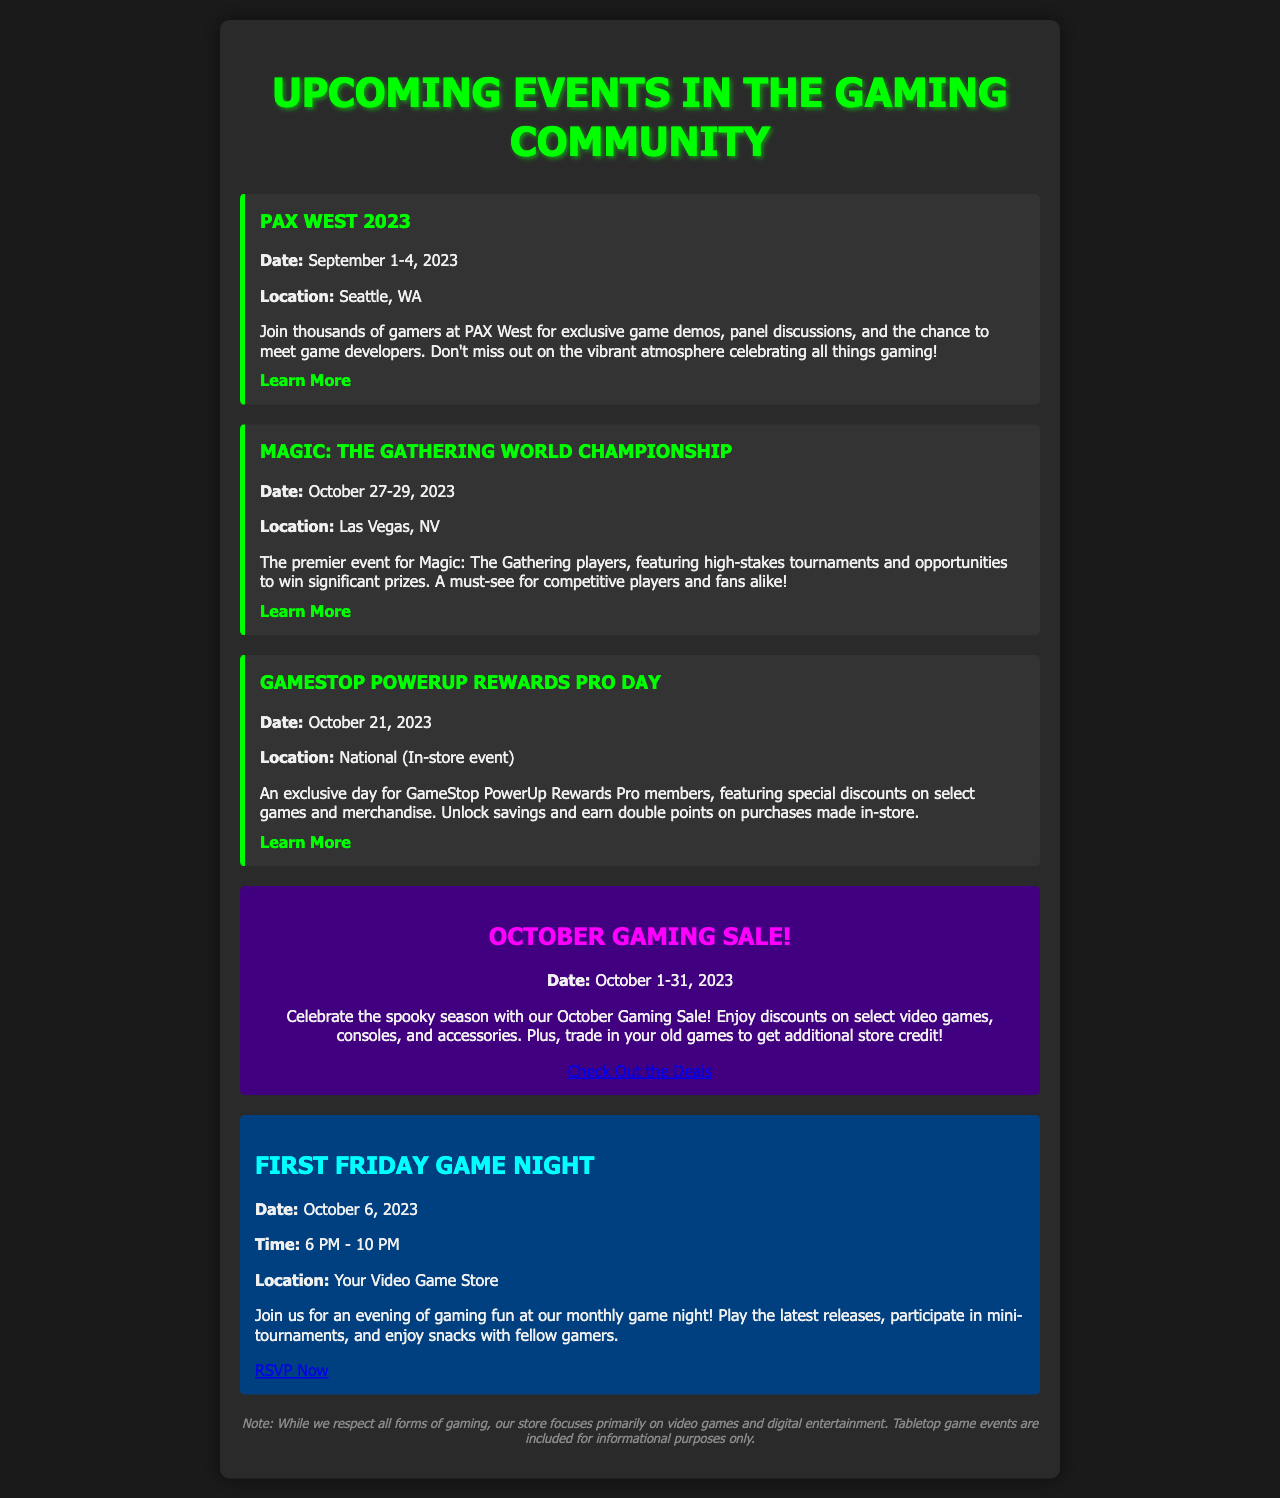What is the date of PAX West 2023? The date for PAX West 2023 is specifically mentioned in the document as September 1-4, 2023.
Answer: September 1-4, 2023 Where is the Magic: The Gathering World Championship held? The location for the Magic: The Gathering World Championship is stated as Las Vegas, NV in the document.
Answer: Las Vegas, NV What can GameStop PowerUp Rewards Pro members earn on purchases made in-store? The document indicates that Pro members can earn double points on purchases made in-store during the PowerUp Rewards Pro Day event.
Answer: Double points When is the October Gaming Sale happening? The document specifies that the October Gaming Sale is taking place from October 1-31, 2023.
Answer: October 1-31, 2023 What time does the First Friday Game Night start? According to the document, the First Friday Game Night starts at 6 PM.
Answer: 6 PM How long does the First Friday Game Night last? The document mentions that the First Friday Game Night lasts until 10 PM, which gives a total duration of 4 hours.
Answer: 4 hours What type of events does the document primarily focus on? The document clearly states that it focuses primarily on video games and digital entertainment while including tabletop games for informational purposes.
Answer: Video games What is the purpose of the October Gaming Sale? As per the document, the purpose is to celebrate the spooky season and offer discounts on select items while encouraging trade-ins for additional credit.
Answer: Discounts and trade-ins 